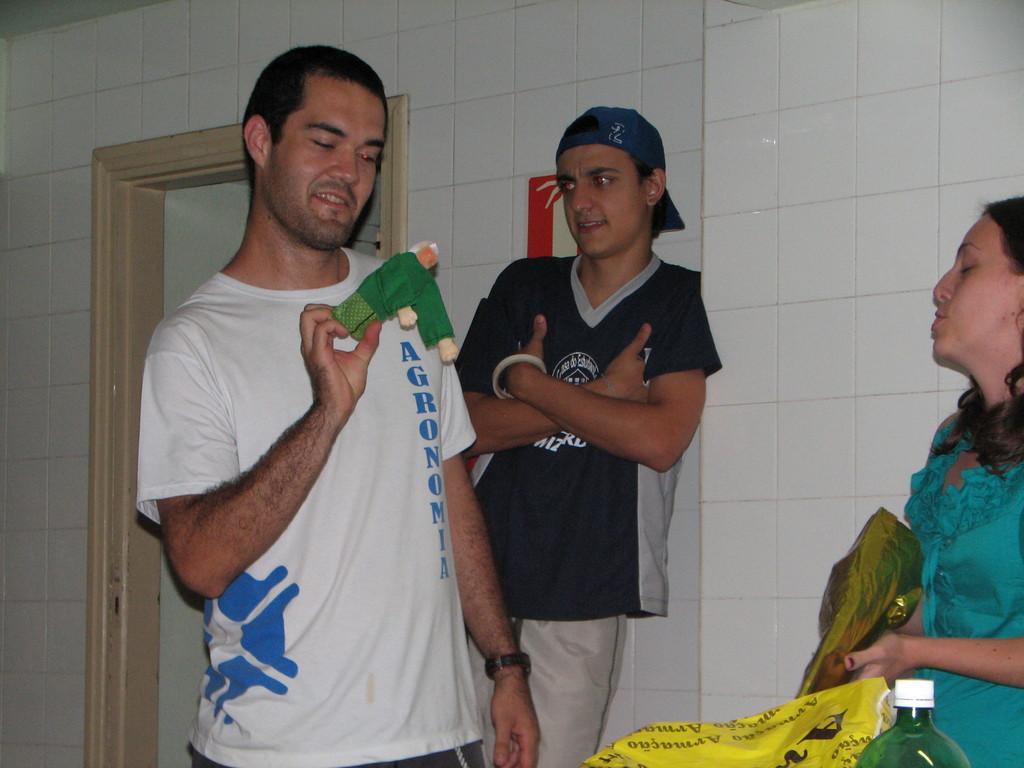Could you give a brief overview of what you see in this image? On the left side a man is standing, he wore white color t-shirt, in the middle a person is leaning to the wall. On the right side a woman is there, she wore green color dress. 